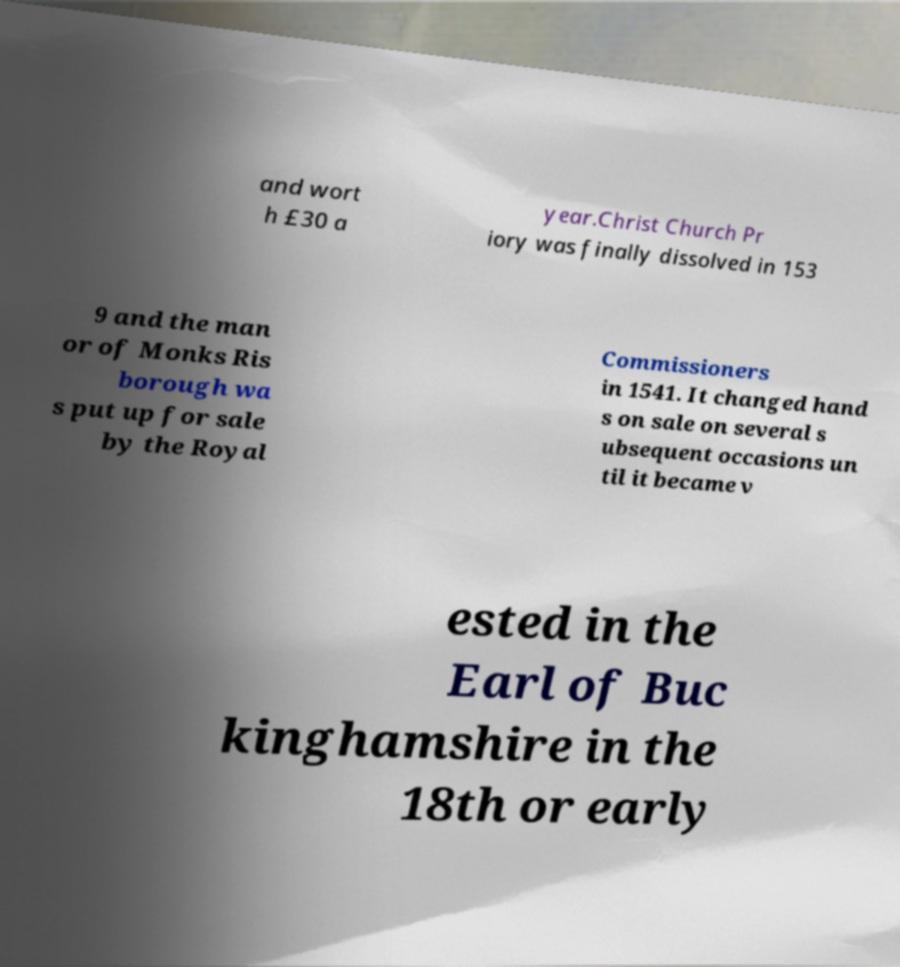What messages or text are displayed in this image? I need them in a readable, typed format. and wort h £30 a year.Christ Church Pr iory was finally dissolved in 153 9 and the man or of Monks Ris borough wa s put up for sale by the Royal Commissioners in 1541. It changed hand s on sale on several s ubsequent occasions un til it became v ested in the Earl of Buc kinghamshire in the 18th or early 